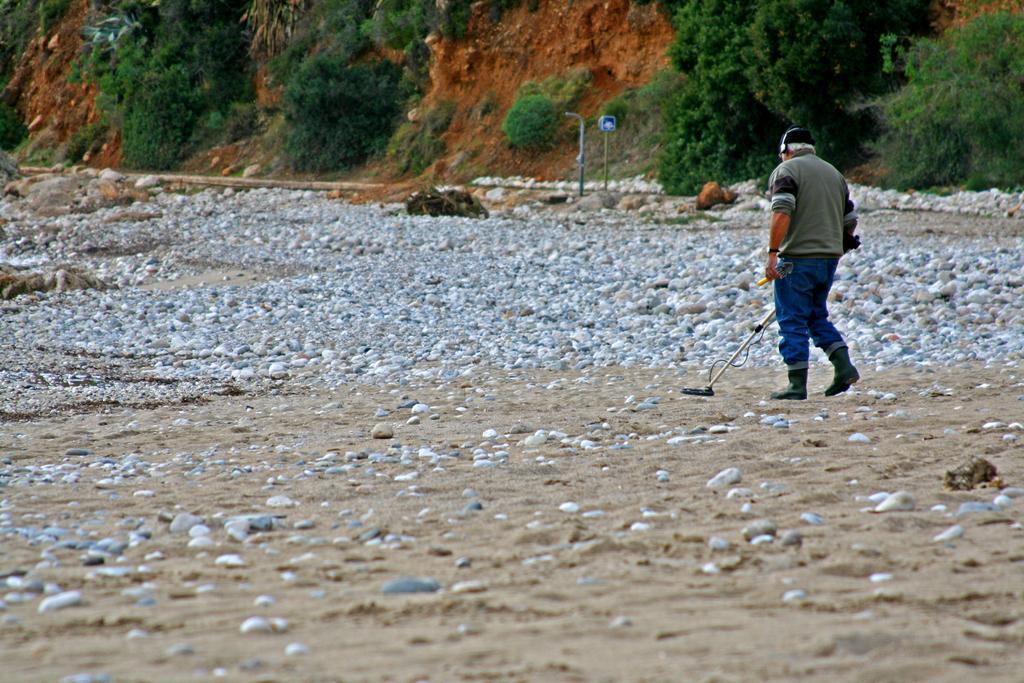Please provide a concise description of this image. On the right side of the image we can see a person standing and he is in a different costume. And we can see he is holding some objects. In the background, we can see trees, stones, poles and a few other objects. 